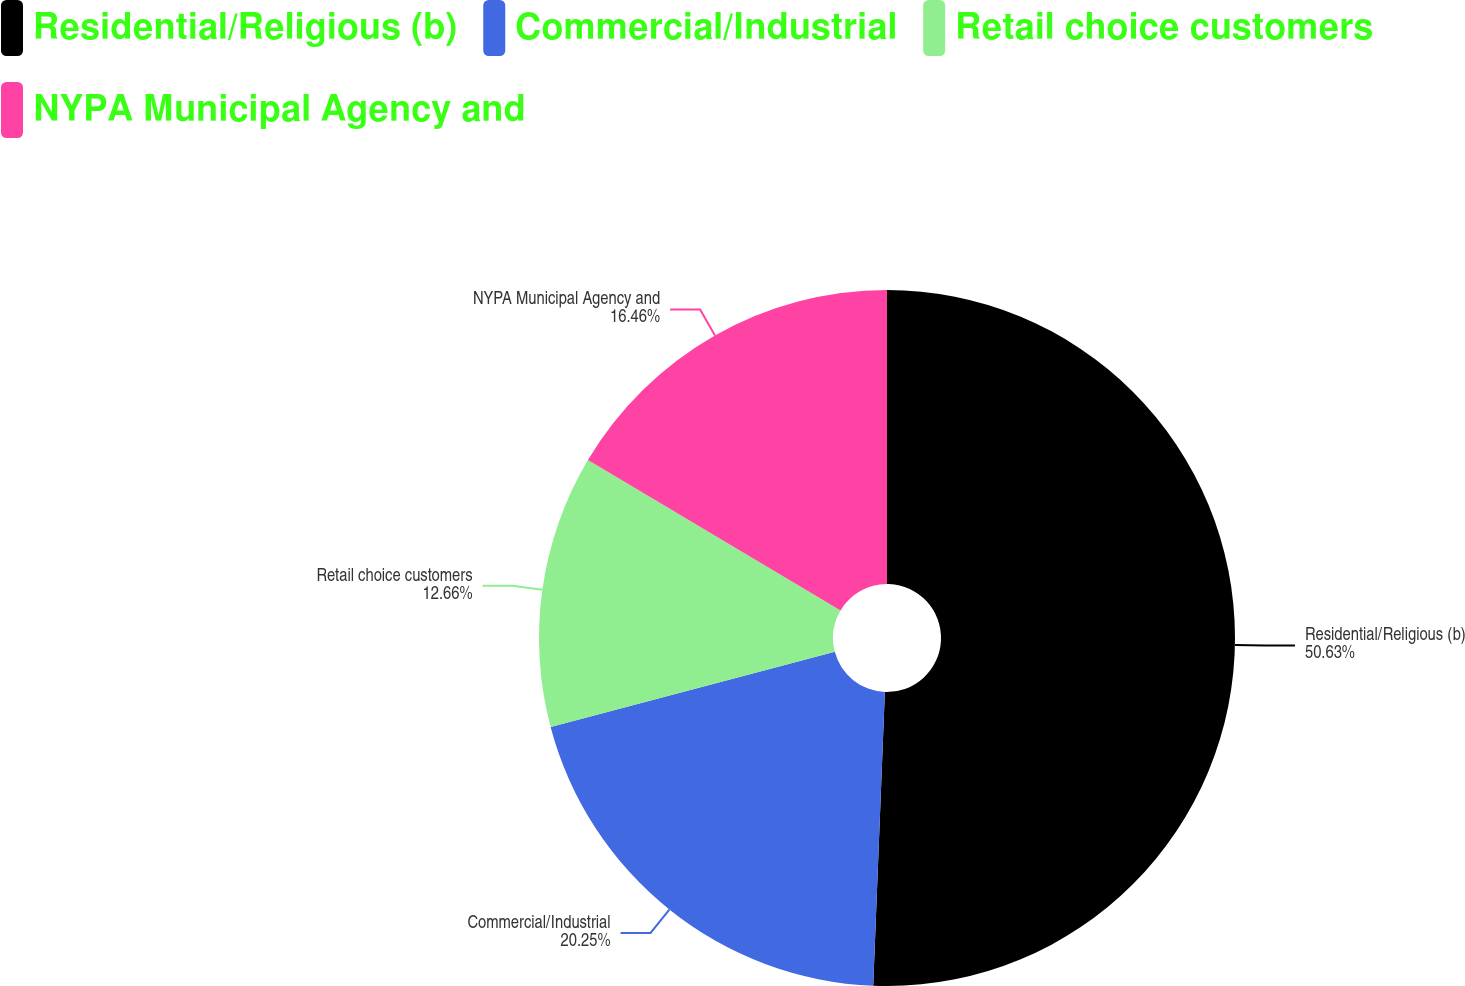Convert chart. <chart><loc_0><loc_0><loc_500><loc_500><pie_chart><fcel>Residential/Religious (b)<fcel>Commercial/Industrial<fcel>Retail choice customers<fcel>NYPA Municipal Agency and<nl><fcel>50.63%<fcel>20.25%<fcel>12.66%<fcel>16.46%<nl></chart> 